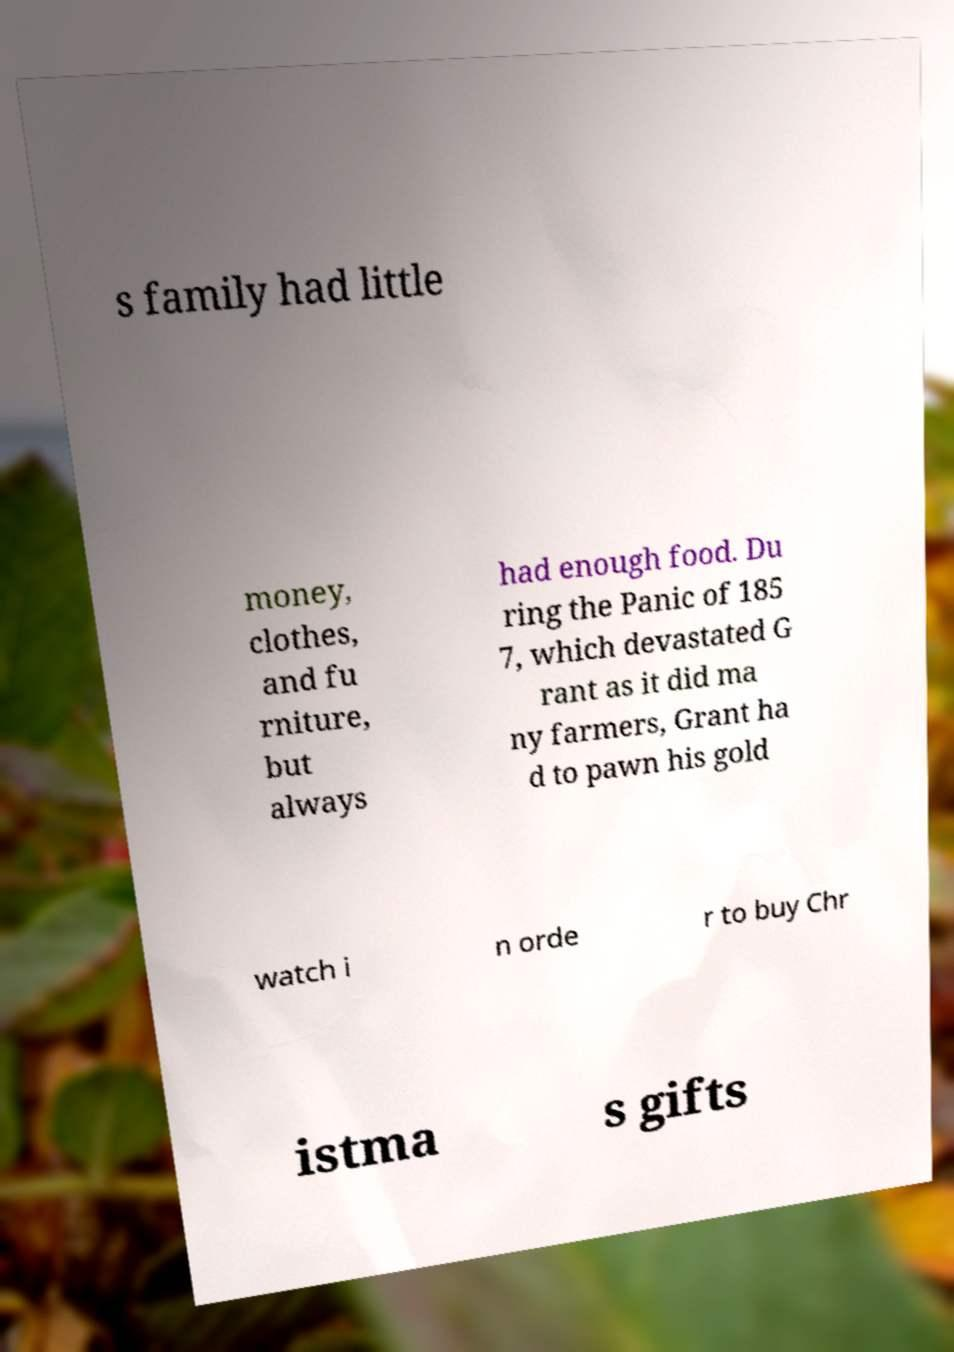For documentation purposes, I need the text within this image transcribed. Could you provide that? s family had little money, clothes, and fu rniture, but always had enough food. Du ring the Panic of 185 7, which devastated G rant as it did ma ny farmers, Grant ha d to pawn his gold watch i n orde r to buy Chr istma s gifts 